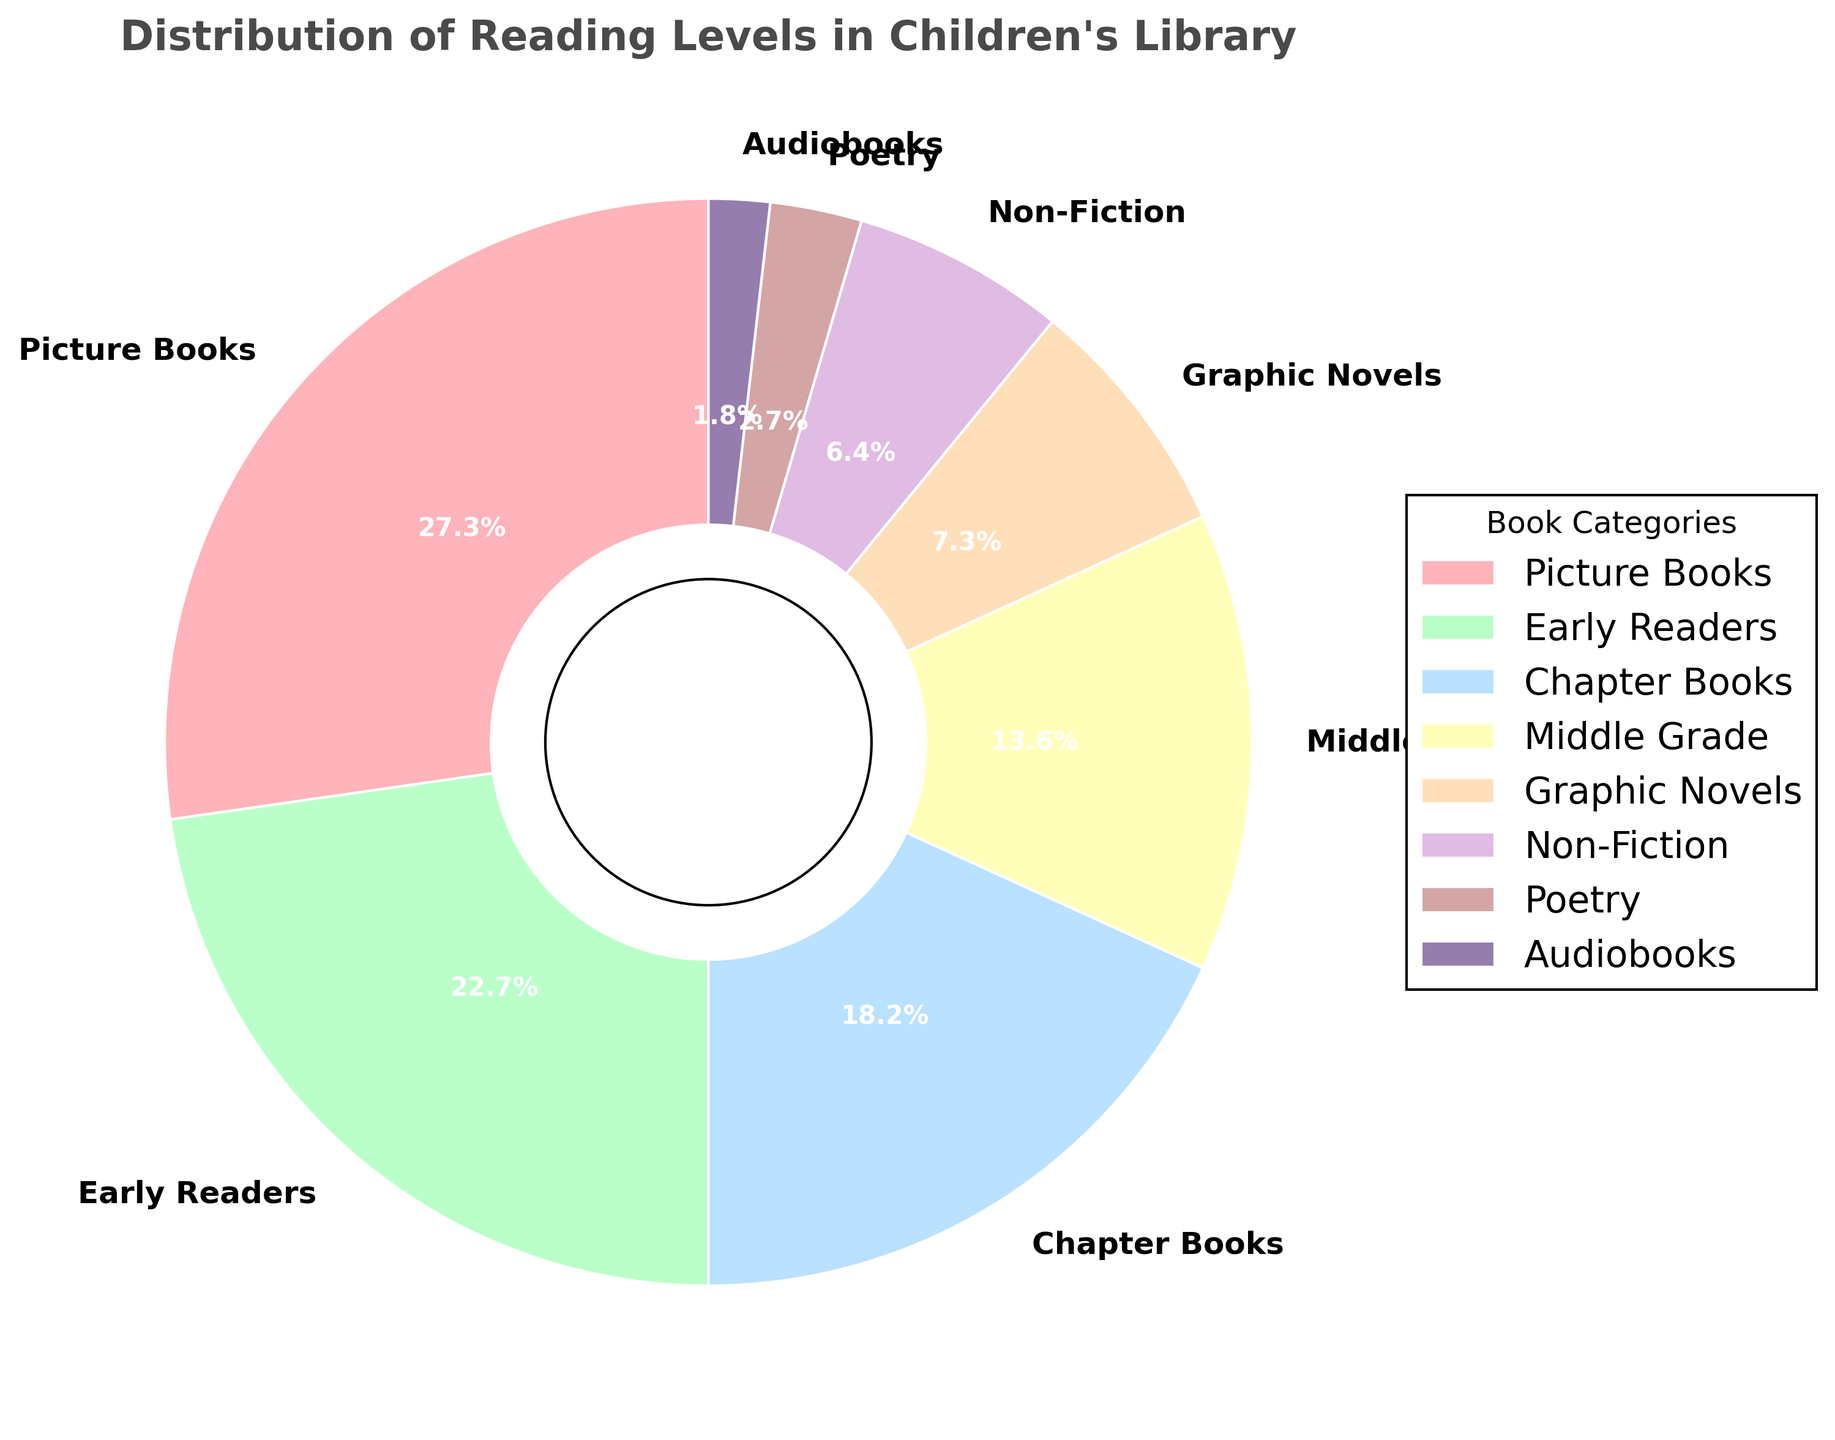Which type of books is the most common in the children's library? The slice labeled "Picture Books" takes up the largest portion of the pie chart, marked as 30%.
Answer: Picture Books Which categories together make up exactly half of the library's collection? "Picture Books" (30%) and "Early Readers" (25%) together sum up to 55%.
Answer: Picture Books and Early Readers Are there more Chapter Books or Middle Grade books, and by how much? "Chapter Books" make up 20% and "Middle Grade" books make up 15%. The difference is 5%.
Answer: Chapter Books by 5% What is the combined percentage of Graphic Novels, Non-Fiction, Poetry, and Audiobooks? Adding the percentages: Graphic Novels (8%) + Non-Fiction (7%) + Poetry (3%) + Audiobooks (2%) equals 20%.
Answer: 20% Which category has the smallest portion, and what percentage is it? The smallest portion is for "Audiobooks", which make up 2%.
Answer: Audiobooks, 2% How much more does the largest category account for compared to the smallest category? "Picture Books" (30%) - "Audiobooks" (2%) equals a difference of 28%.
Answer: 28% If you combine all books except Picture Books, what percentage do they account for? Total percentage without Picture Books: 100% - 30% = 70%.
Answer: 70% Are there more Early Readers or Graphic Novels, and by how much? "Early Readers" make up 25% and "Graphic Novels" make up 8%. The difference is 17%.
Answer: Early Readers by 17% What is the total percentage of books that are not Chapter Books or Middle Grade books? Total percentage without Chapter Books and Middle Grade: 100% - (20% + 15%) = 65%.
Answer: 65% If you were to pick a book randomly, what is the probability that it would be a Poetry book? The probability is the percentage of Poetry books, which is 3%.
Answer: 3% 